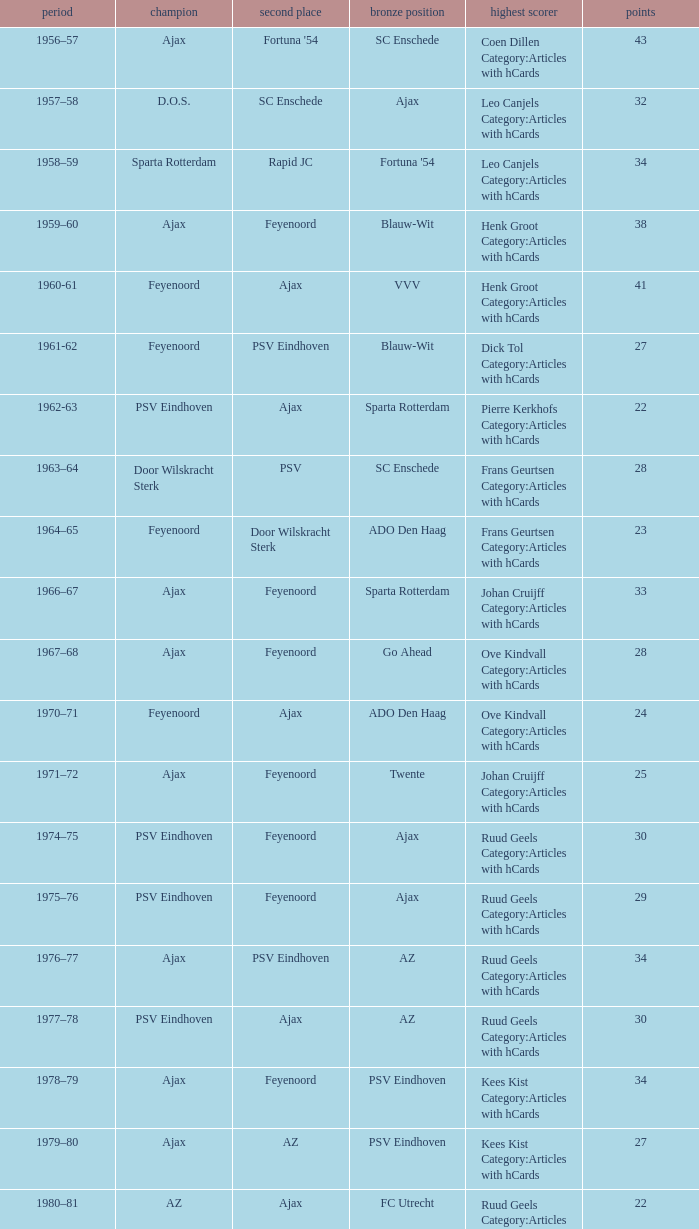When az is the runner up nad feyenoord came in third place how many overall winners are there? 1.0. 